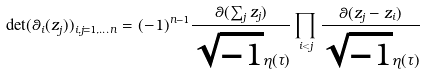<formula> <loc_0><loc_0><loc_500><loc_500>\det ( \theta _ { i } ( z _ { j } ) ) _ { i , j = 1 , \dots n } = ( - 1 ) ^ { n - 1 } \frac { \theta ( \sum _ { j } z _ { j } ) } { \sqrt { - 1 } { \eta } ( \tau ) } \prod _ { i < j } \frac { \theta ( z _ { j } - z _ { i } ) } { \sqrt { - 1 } { \eta } ( \tau ) }</formula> 